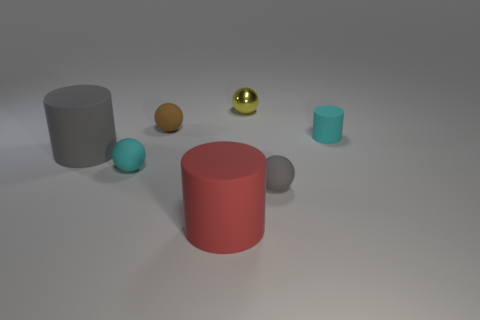There is a cyan matte object that is in front of the cyan cylinder; is its shape the same as the gray rubber thing right of the brown thing? yes 